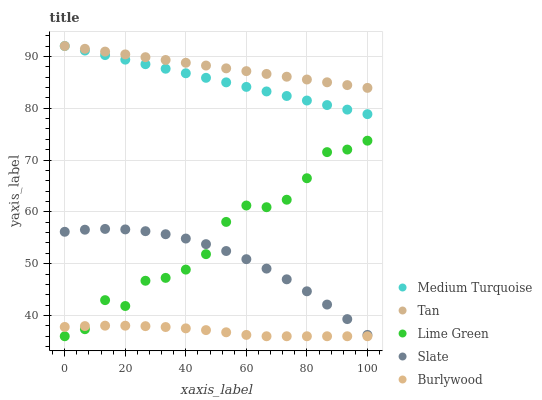Does Burlywood have the minimum area under the curve?
Answer yes or no. Yes. Does Tan have the maximum area under the curve?
Answer yes or no. Yes. Does Lime Green have the minimum area under the curve?
Answer yes or no. No. Does Lime Green have the maximum area under the curve?
Answer yes or no. No. Is Medium Turquoise the smoothest?
Answer yes or no. Yes. Is Lime Green the roughest?
Answer yes or no. Yes. Is Tan the smoothest?
Answer yes or no. No. Is Tan the roughest?
Answer yes or no. No. Does Burlywood have the lowest value?
Answer yes or no. Yes. Does Tan have the lowest value?
Answer yes or no. No. Does Medium Turquoise have the highest value?
Answer yes or no. Yes. Does Lime Green have the highest value?
Answer yes or no. No. Is Slate less than Medium Turquoise?
Answer yes or no. Yes. Is Tan greater than Slate?
Answer yes or no. Yes. Does Lime Green intersect Burlywood?
Answer yes or no. Yes. Is Lime Green less than Burlywood?
Answer yes or no. No. Is Lime Green greater than Burlywood?
Answer yes or no. No. Does Slate intersect Medium Turquoise?
Answer yes or no. No. 